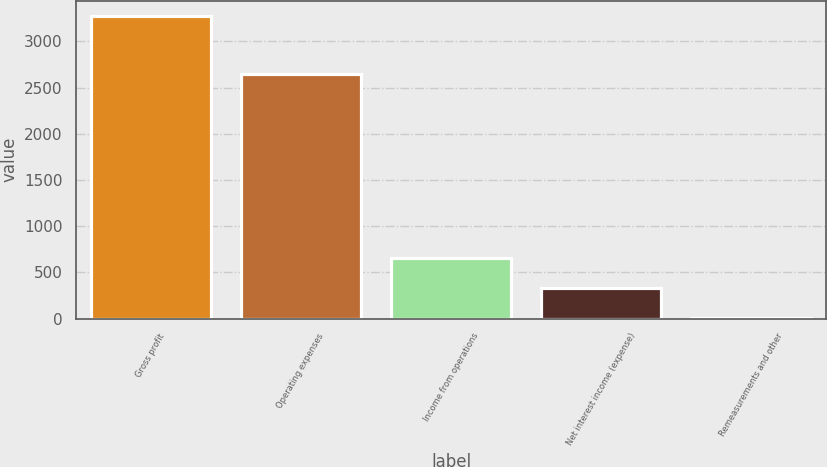Convert chart. <chart><loc_0><loc_0><loc_500><loc_500><bar_chart><fcel>Gross profit<fcel>Operating expenses<fcel>Income from operations<fcel>Net interest income (expense)<fcel>Remeasurements and other<nl><fcel>3274<fcel>2648<fcel>659.6<fcel>332.8<fcel>6<nl></chart> 